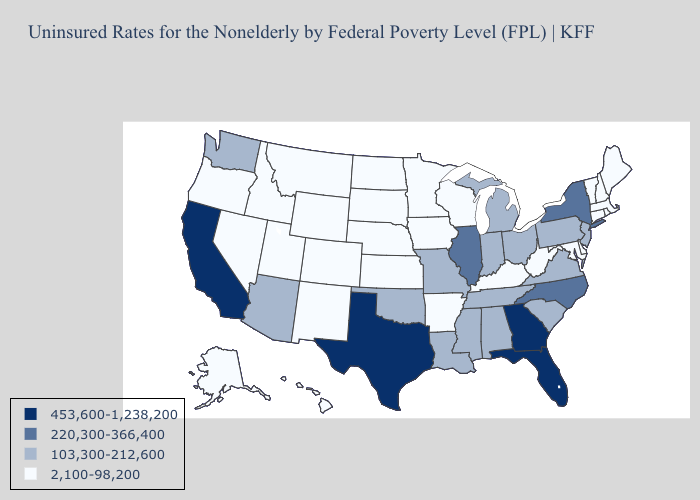Name the states that have a value in the range 220,300-366,400?
Keep it brief. Illinois, New York, North Carolina. What is the value of Wisconsin?
Keep it brief. 2,100-98,200. Name the states that have a value in the range 453,600-1,238,200?
Be succinct. California, Florida, Georgia, Texas. Name the states that have a value in the range 220,300-366,400?
Short answer required. Illinois, New York, North Carolina. Which states have the lowest value in the USA?
Write a very short answer. Alaska, Arkansas, Colorado, Connecticut, Delaware, Hawaii, Idaho, Iowa, Kansas, Kentucky, Maine, Maryland, Massachusetts, Minnesota, Montana, Nebraska, Nevada, New Hampshire, New Mexico, North Dakota, Oregon, Rhode Island, South Dakota, Utah, Vermont, West Virginia, Wisconsin, Wyoming. Name the states that have a value in the range 2,100-98,200?
Short answer required. Alaska, Arkansas, Colorado, Connecticut, Delaware, Hawaii, Idaho, Iowa, Kansas, Kentucky, Maine, Maryland, Massachusetts, Minnesota, Montana, Nebraska, Nevada, New Hampshire, New Mexico, North Dakota, Oregon, Rhode Island, South Dakota, Utah, Vermont, West Virginia, Wisconsin, Wyoming. Name the states that have a value in the range 103,300-212,600?
Concise answer only. Alabama, Arizona, Indiana, Louisiana, Michigan, Mississippi, Missouri, New Jersey, Ohio, Oklahoma, Pennsylvania, South Carolina, Tennessee, Virginia, Washington. Name the states that have a value in the range 2,100-98,200?
Quick response, please. Alaska, Arkansas, Colorado, Connecticut, Delaware, Hawaii, Idaho, Iowa, Kansas, Kentucky, Maine, Maryland, Massachusetts, Minnesota, Montana, Nebraska, Nevada, New Hampshire, New Mexico, North Dakota, Oregon, Rhode Island, South Dakota, Utah, Vermont, West Virginia, Wisconsin, Wyoming. Does Colorado have the lowest value in the West?
Give a very brief answer. Yes. What is the value of Hawaii?
Short answer required. 2,100-98,200. Which states hav the highest value in the South?
Be succinct. Florida, Georgia, Texas. What is the value of Florida?
Keep it brief. 453,600-1,238,200. What is the highest value in the Northeast ?
Short answer required. 220,300-366,400. Does the map have missing data?
Keep it brief. No. How many symbols are there in the legend?
Give a very brief answer. 4. 